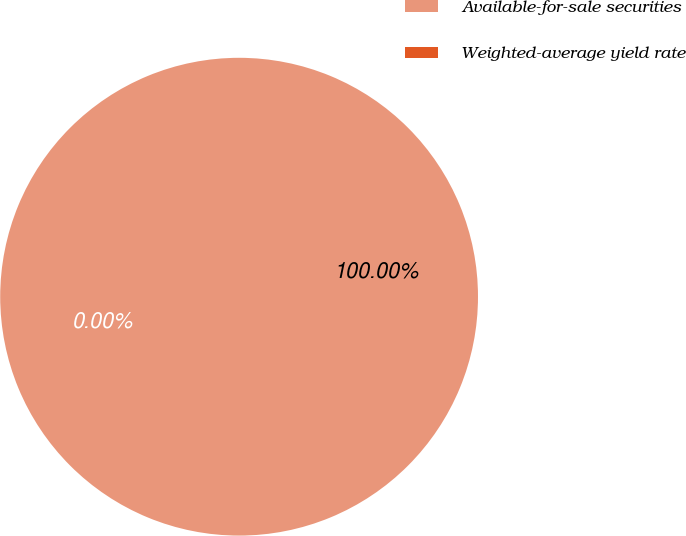Convert chart. <chart><loc_0><loc_0><loc_500><loc_500><pie_chart><fcel>Available-for-sale securities<fcel>Weighted-average yield rate<nl><fcel>100.0%<fcel>0.0%<nl></chart> 